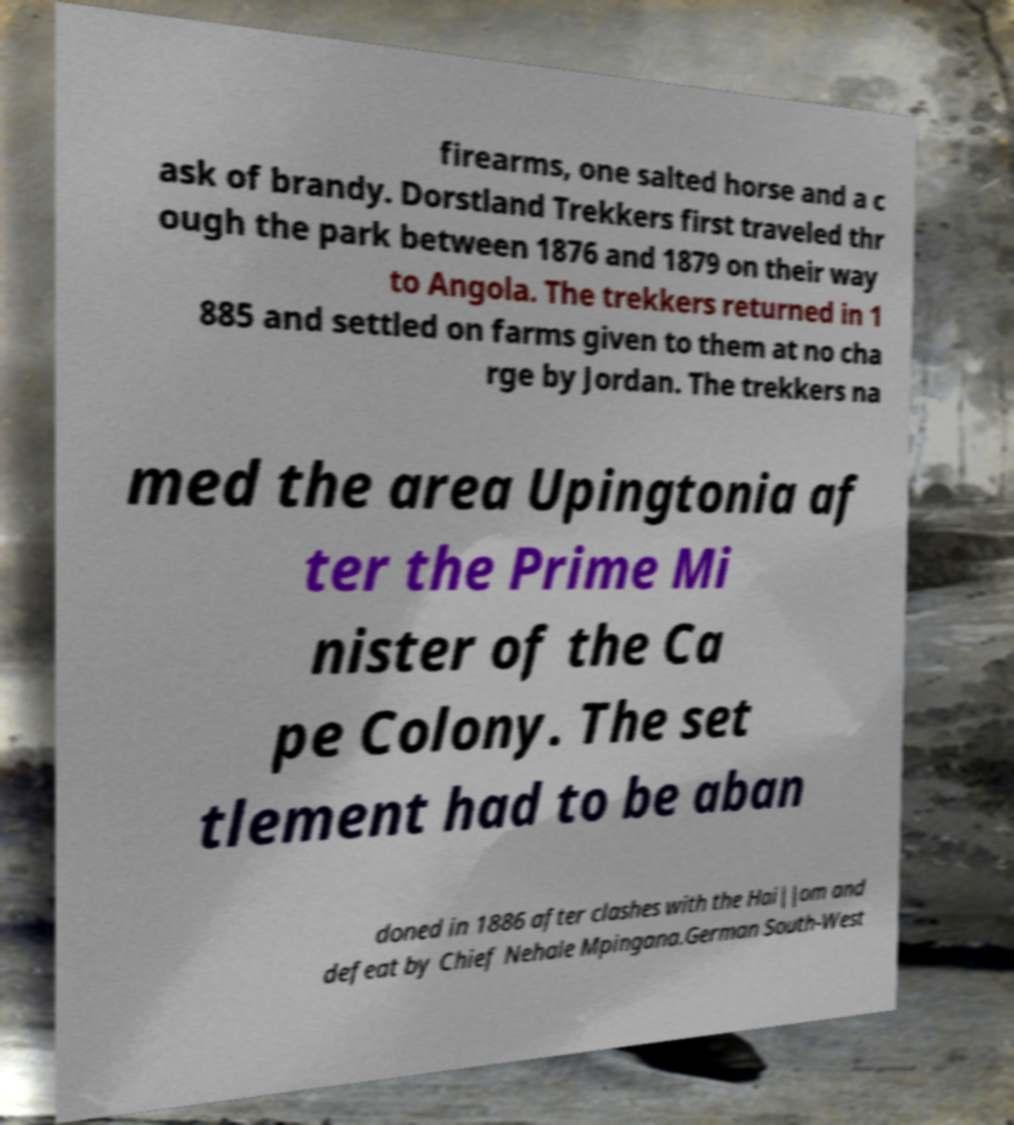What messages or text are displayed in this image? I need them in a readable, typed format. firearms, one salted horse and a c ask of brandy. Dorstland Trekkers first traveled thr ough the park between 1876 and 1879 on their way to Angola. The trekkers returned in 1 885 and settled on farms given to them at no cha rge by Jordan. The trekkers na med the area Upingtonia af ter the Prime Mi nister of the Ca pe Colony. The set tlement had to be aban doned in 1886 after clashes with the Hai||om and defeat by Chief Nehale Mpingana.German South-West 